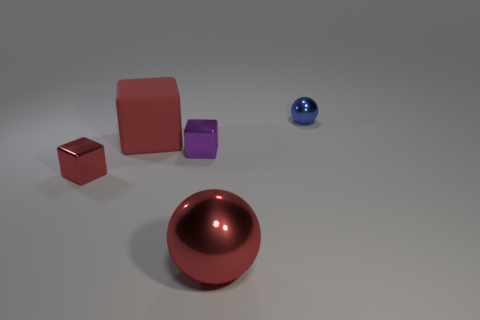Is there any other thing that has the same material as the large block?
Offer a terse response. No. Are there fewer red matte things that are behind the large red cube than brown rubber spheres?
Your answer should be compact. No. What color is the small metallic block that is right of the rubber thing?
Ensure brevity in your answer.  Purple. There is a sphere that is in front of the thing on the right side of the big red shiny object; what is it made of?
Give a very brief answer. Metal. Is there a red matte ball that has the same size as the red rubber thing?
Provide a short and direct response. No. How many objects are shiny objects that are left of the purple cube or cubes that are in front of the purple object?
Your answer should be compact. 1. Does the red metallic thing behind the red metal sphere have the same size as the red thing that is right of the purple shiny cube?
Make the answer very short. No. There is a small blue shiny thing that is right of the purple block; are there any metal objects in front of it?
Your response must be concise. Yes. What number of metallic spheres are to the left of the large block?
Ensure brevity in your answer.  0. How many other objects are the same color as the rubber object?
Ensure brevity in your answer.  2. 